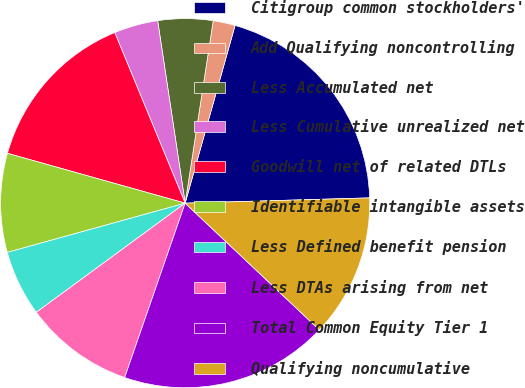Convert chart to OTSL. <chart><loc_0><loc_0><loc_500><loc_500><pie_chart><fcel>Citigroup common stockholders'<fcel>Add Qualifying noncontrolling<fcel>Less Accumulated net<fcel>Less Cumulative unrealized net<fcel>Goodwill net of related DTLs<fcel>Identifiable intangible assets<fcel>Less Defined benefit pension<fcel>Less DTAs arising from net<fcel>Total Common Equity Tier 1<fcel>Qualifying noncumulative<nl><fcel>20.19%<fcel>1.93%<fcel>4.81%<fcel>3.85%<fcel>14.42%<fcel>8.65%<fcel>5.77%<fcel>9.62%<fcel>18.27%<fcel>12.5%<nl></chart> 